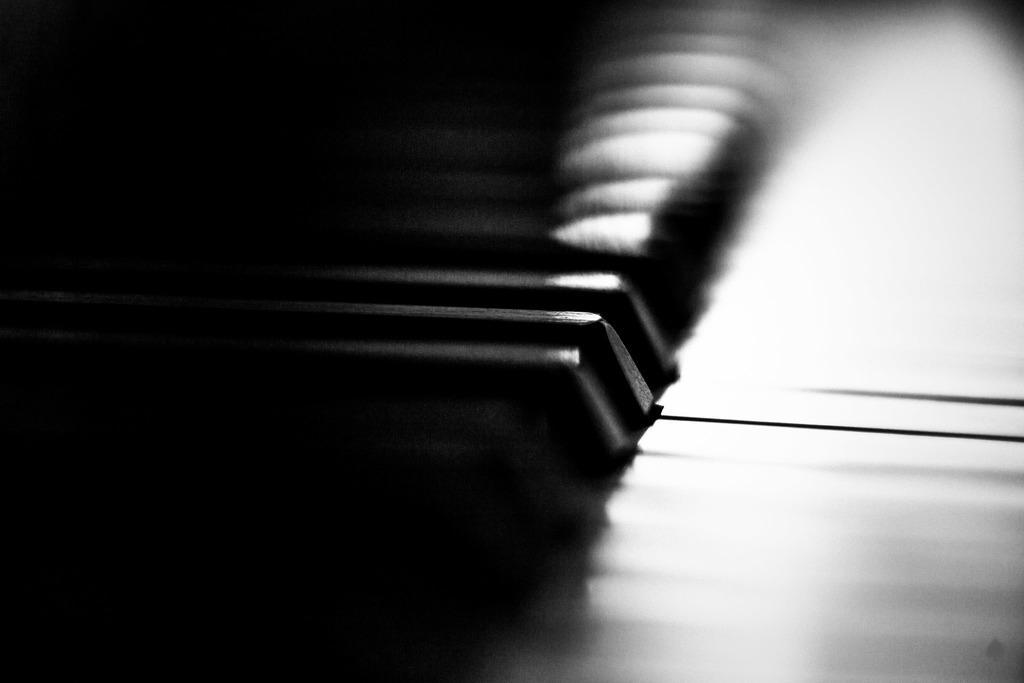Please provide a concise description of this image. This image consists of a piano. The background is too dark and blurred. 